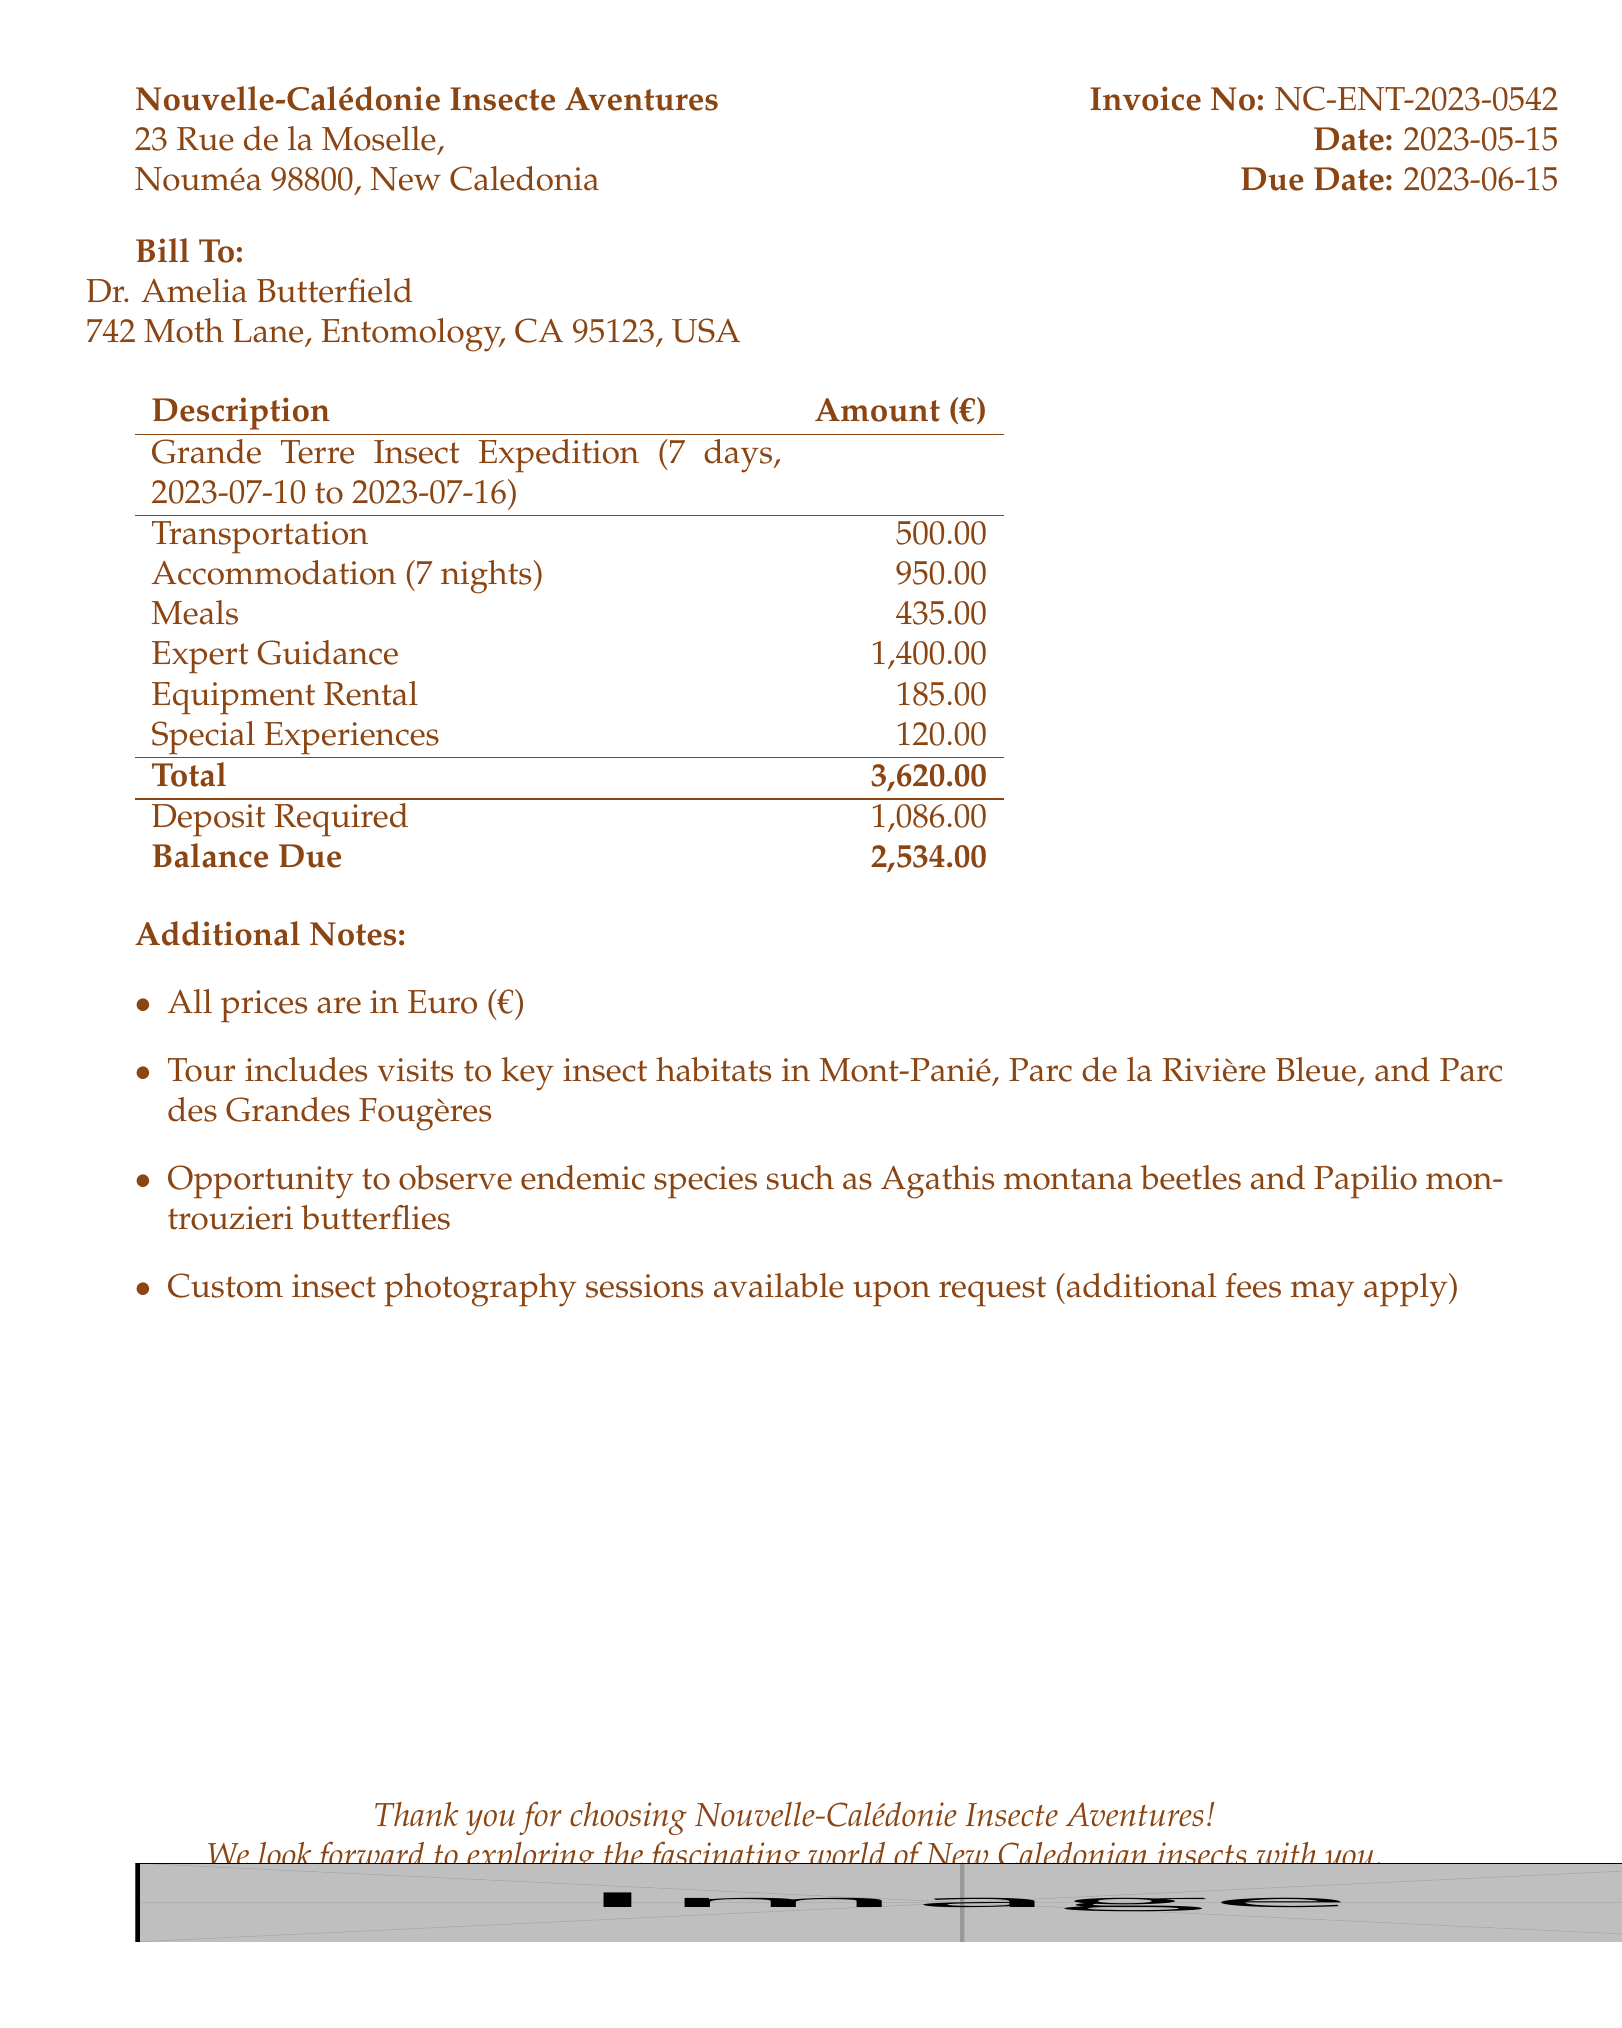What is the invoice number? The invoice number is a specific reference assigned to the document, found in the invoice details.
Answer: NC-ENT-2023-0542 What is the total cost of the tour? The total cost summarizes all the expenses listed in the document, including transportation, accommodation, meals, expert guidance, equipment, and special experiences.
Answer: 3620 Who is the guiding expert for the Coleoptera? The document lists the experts providing guidance, specifically indicating the specialization of Dr. Jean-Pierre Delage.
Answer: Dr. Jean-Pierre Delage How many nights of accommodation are provided in total? The total number of nights is calculated based on the accommodation details for different locations in the document.
Answer: 7 What is the cost per day for expert guidance? The cost per day for expert guidance is specified for both experts in the guidance section of the document.
Answer: 200 What is the balance due? The balance due represents the remaining amount to be paid after the deposit, specified in the financial summary section.
Answer: 2534 What are the names of the accommodations listed? The names of accommodations include those mentioned under the accommodation section, each specifying its location and price.
Answer: Hotel Le Lagon, Kanua Tera Ecolodge, Hôtel Koulnoué Village What special experience is available for night insect observation? The special experiences section provides a specific activity listed for night insect spotting in the document.
Answer: Night insect spotting tour How many days is the Grande Terre Insect Expedition? The duration of the tour package is clearly indicated in the overview of the tour package section.
Answer: 7 days 